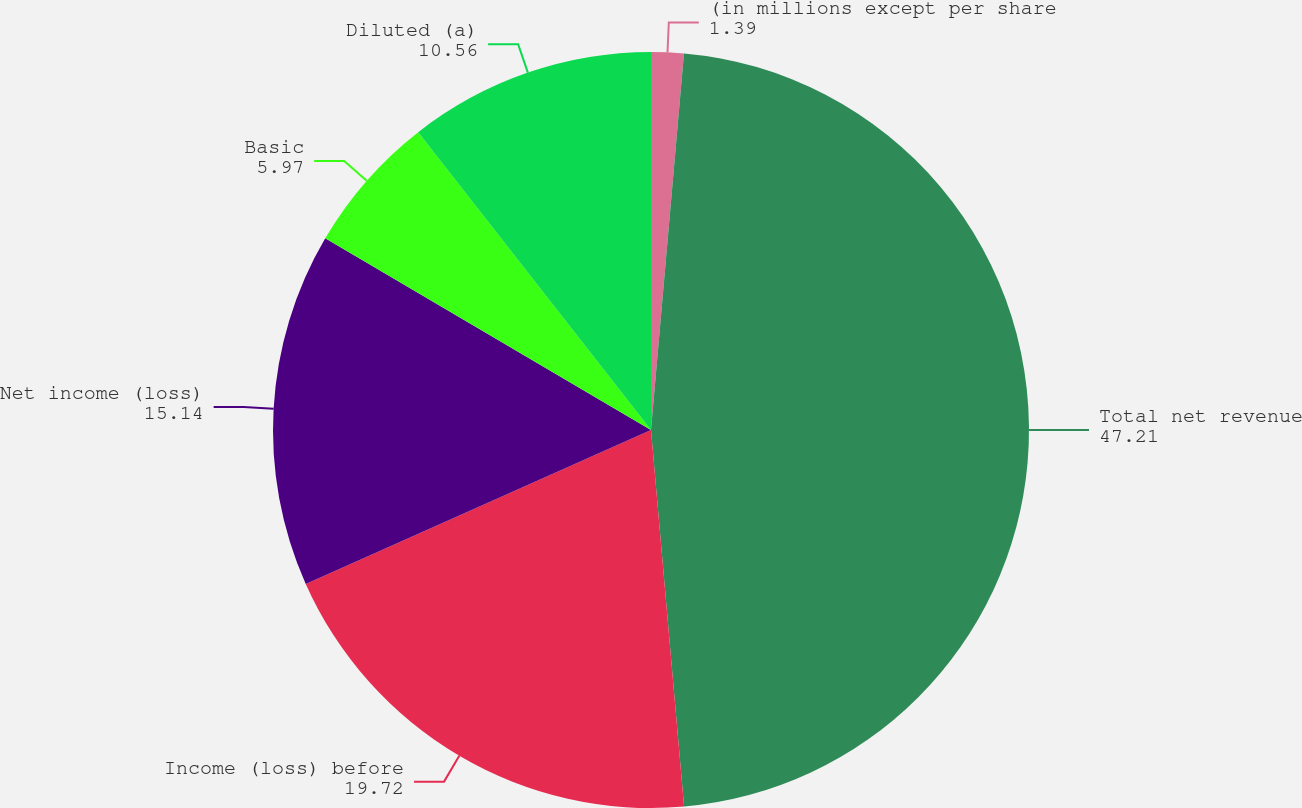<chart> <loc_0><loc_0><loc_500><loc_500><pie_chart><fcel>(in millions except per share<fcel>Total net revenue<fcel>Income (loss) before<fcel>Net income (loss)<fcel>Basic<fcel>Diluted (a)<nl><fcel>1.39%<fcel>47.21%<fcel>19.72%<fcel>15.14%<fcel>5.97%<fcel>10.56%<nl></chart> 